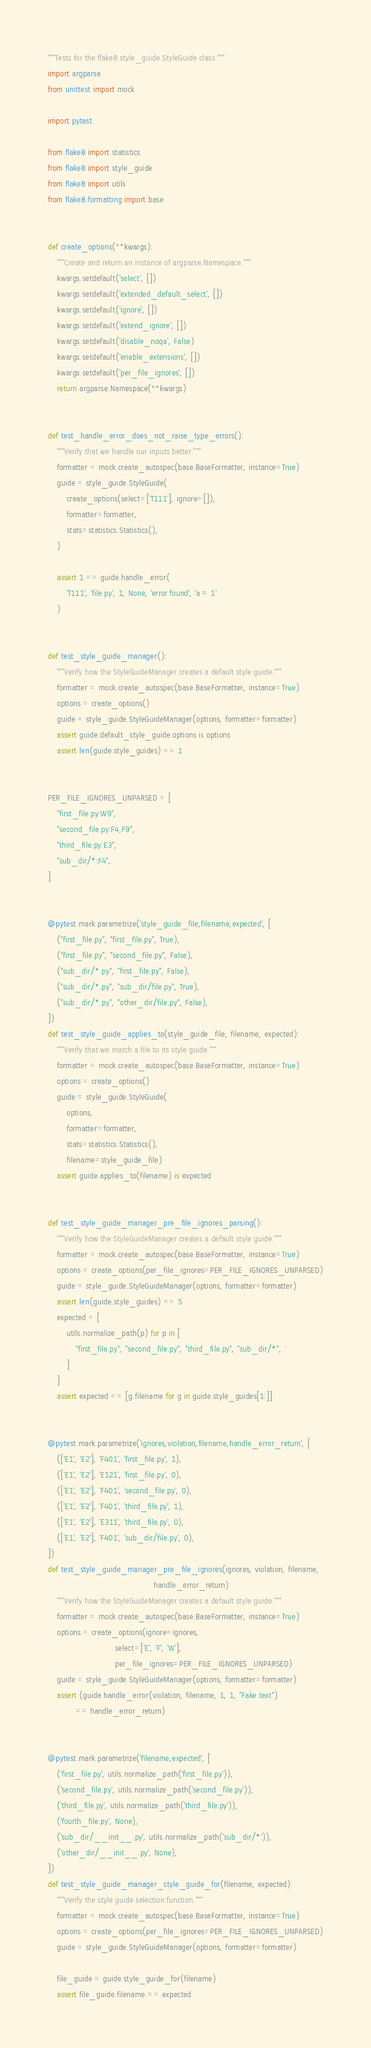Convert code to text. <code><loc_0><loc_0><loc_500><loc_500><_Python_>"""Tests for the flake8.style_guide.StyleGuide class."""
import argparse
from unittest import mock

import pytest

from flake8 import statistics
from flake8 import style_guide
from flake8 import utils
from flake8.formatting import base


def create_options(**kwargs):
    """Create and return an instance of argparse.Namespace."""
    kwargs.setdefault('select', [])
    kwargs.setdefault('extended_default_select', [])
    kwargs.setdefault('ignore', [])
    kwargs.setdefault('extend_ignore', [])
    kwargs.setdefault('disable_noqa', False)
    kwargs.setdefault('enable_extensions', [])
    kwargs.setdefault('per_file_ignores', [])
    return argparse.Namespace(**kwargs)


def test_handle_error_does_not_raise_type_errors():
    """Verify that we handle our inputs better."""
    formatter = mock.create_autospec(base.BaseFormatter, instance=True)
    guide = style_guide.StyleGuide(
        create_options(select=['T111'], ignore=[]),
        formatter=formatter,
        stats=statistics.Statistics(),
    )

    assert 1 == guide.handle_error(
        'T111', 'file.py', 1, None, 'error found', 'a = 1'
    )


def test_style_guide_manager():
    """Verify how the StyleGuideManager creates a default style guide."""
    formatter = mock.create_autospec(base.BaseFormatter, instance=True)
    options = create_options()
    guide = style_guide.StyleGuideManager(options, formatter=formatter)
    assert guide.default_style_guide.options is options
    assert len(guide.style_guides) == 1


PER_FILE_IGNORES_UNPARSED = [
    "first_file.py:W9",
    "second_file.py:F4,F9",
    "third_file.py:E3",
    "sub_dir/*:F4",
]


@pytest.mark.parametrize('style_guide_file,filename,expected', [
    ("first_file.py", "first_file.py", True),
    ("first_file.py", "second_file.py", False),
    ("sub_dir/*.py", "first_file.py", False),
    ("sub_dir/*.py", "sub_dir/file.py", True),
    ("sub_dir/*.py", "other_dir/file.py", False),
])
def test_style_guide_applies_to(style_guide_file, filename, expected):
    """Verify that we match a file to its style guide."""
    formatter = mock.create_autospec(base.BaseFormatter, instance=True)
    options = create_options()
    guide = style_guide.StyleGuide(
        options,
        formatter=formatter,
        stats=statistics.Statistics(),
        filename=style_guide_file)
    assert guide.applies_to(filename) is expected


def test_style_guide_manager_pre_file_ignores_parsing():
    """Verify how the StyleGuideManager creates a default style guide."""
    formatter = mock.create_autospec(base.BaseFormatter, instance=True)
    options = create_options(per_file_ignores=PER_FILE_IGNORES_UNPARSED)
    guide = style_guide.StyleGuideManager(options, formatter=formatter)
    assert len(guide.style_guides) == 5
    expected = [
        utils.normalize_path(p) for p in [
            "first_file.py", "second_file.py", "third_file.py", "sub_dir/*",
        ]
    ]
    assert expected == [g.filename for g in guide.style_guides[1:]]


@pytest.mark.parametrize('ignores,violation,filename,handle_error_return', [
    (['E1', 'E2'], 'F401', 'first_file.py', 1),
    (['E1', 'E2'], 'E121', 'first_file.py', 0),
    (['E1', 'E2'], 'F401', 'second_file.py', 0),
    (['E1', 'E2'], 'F401', 'third_file.py', 1),
    (['E1', 'E2'], 'E311', 'third_file.py', 0),
    (['E1', 'E2'], 'F401', 'sub_dir/file.py', 0),
])
def test_style_guide_manager_pre_file_ignores(ignores, violation, filename,
                                              handle_error_return):
    """Verify how the StyleGuideManager creates a default style guide."""
    formatter = mock.create_autospec(base.BaseFormatter, instance=True)
    options = create_options(ignore=ignores,
                             select=['E', 'F', 'W'],
                             per_file_ignores=PER_FILE_IGNORES_UNPARSED)
    guide = style_guide.StyleGuideManager(options, formatter=formatter)
    assert (guide.handle_error(violation, filename, 1, 1, "Fake text")
            == handle_error_return)


@pytest.mark.parametrize('filename,expected', [
    ('first_file.py', utils.normalize_path('first_file.py')),
    ('second_file.py', utils.normalize_path('second_file.py')),
    ('third_file.py', utils.normalize_path('third_file.py')),
    ('fourth_file.py', None),
    ('sub_dir/__init__.py', utils.normalize_path('sub_dir/*')),
    ('other_dir/__init__.py', None),
])
def test_style_guide_manager_style_guide_for(filename, expected):
    """Verify the style guide selection function."""
    formatter = mock.create_autospec(base.BaseFormatter, instance=True)
    options = create_options(per_file_ignores=PER_FILE_IGNORES_UNPARSED)
    guide = style_guide.StyleGuideManager(options, formatter=formatter)

    file_guide = guide.style_guide_for(filename)
    assert file_guide.filename == expected
</code> 